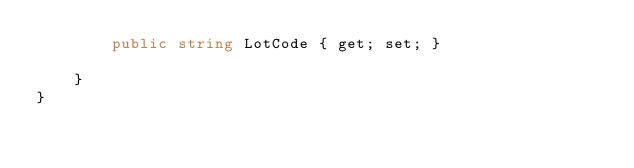<code> <loc_0><loc_0><loc_500><loc_500><_C#_>        public string LotCode { get; set; }

    }
}</code> 